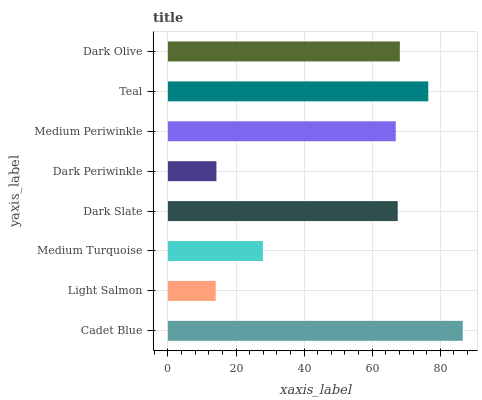Is Light Salmon the minimum?
Answer yes or no. Yes. Is Cadet Blue the maximum?
Answer yes or no. Yes. Is Medium Turquoise the minimum?
Answer yes or no. No. Is Medium Turquoise the maximum?
Answer yes or no. No. Is Medium Turquoise greater than Light Salmon?
Answer yes or no. Yes. Is Light Salmon less than Medium Turquoise?
Answer yes or no. Yes. Is Light Salmon greater than Medium Turquoise?
Answer yes or no. No. Is Medium Turquoise less than Light Salmon?
Answer yes or no. No. Is Dark Slate the high median?
Answer yes or no. Yes. Is Medium Periwinkle the low median?
Answer yes or no. Yes. Is Teal the high median?
Answer yes or no. No. Is Cadet Blue the low median?
Answer yes or no. No. 